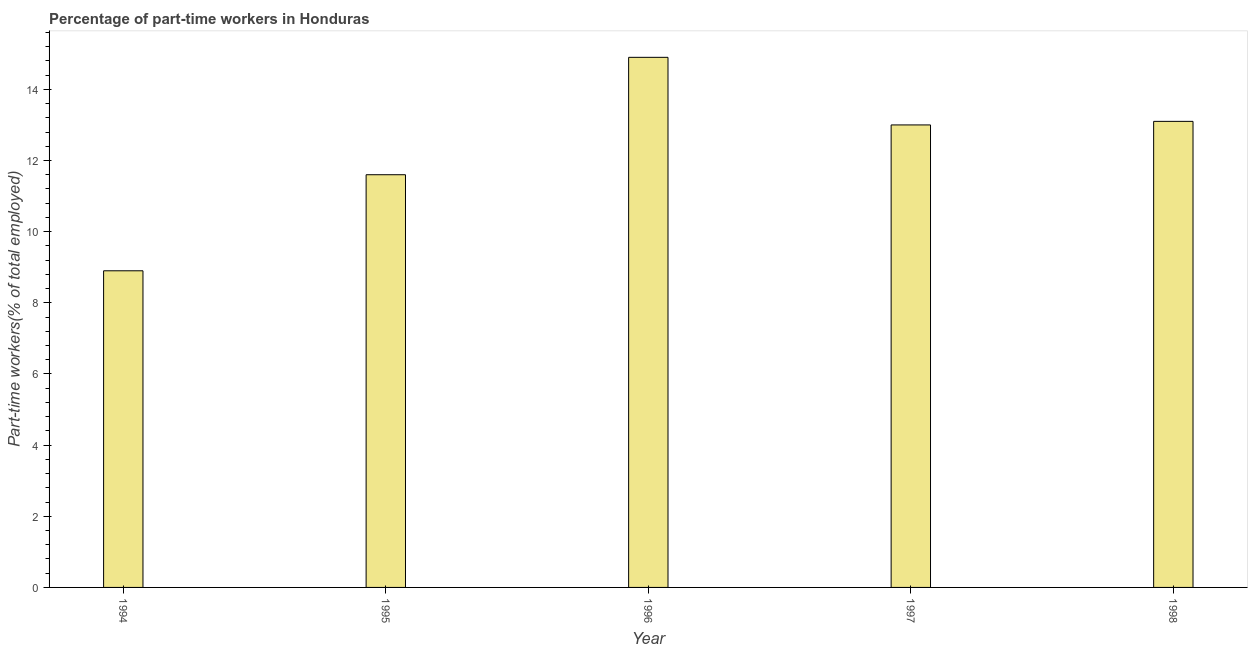What is the title of the graph?
Provide a short and direct response. Percentage of part-time workers in Honduras. What is the label or title of the Y-axis?
Provide a succinct answer. Part-time workers(% of total employed). What is the percentage of part-time workers in 1997?
Your response must be concise. 13. Across all years, what is the maximum percentage of part-time workers?
Keep it short and to the point. 14.9. Across all years, what is the minimum percentage of part-time workers?
Ensure brevity in your answer.  8.9. In which year was the percentage of part-time workers minimum?
Ensure brevity in your answer.  1994. What is the sum of the percentage of part-time workers?
Offer a very short reply. 61.5. What is the difference between the percentage of part-time workers in 1996 and 1997?
Your answer should be compact. 1.9. In how many years, is the percentage of part-time workers greater than 12.8 %?
Provide a short and direct response. 3. What is the ratio of the percentage of part-time workers in 1996 to that in 1998?
Your answer should be very brief. 1.14. Is the percentage of part-time workers in 1996 less than that in 1998?
Give a very brief answer. No. What is the difference between the highest and the lowest percentage of part-time workers?
Give a very brief answer. 6. How many bars are there?
Ensure brevity in your answer.  5. How many years are there in the graph?
Your answer should be very brief. 5. Are the values on the major ticks of Y-axis written in scientific E-notation?
Give a very brief answer. No. What is the Part-time workers(% of total employed) in 1994?
Your answer should be compact. 8.9. What is the Part-time workers(% of total employed) in 1995?
Your response must be concise. 11.6. What is the Part-time workers(% of total employed) of 1996?
Keep it short and to the point. 14.9. What is the Part-time workers(% of total employed) of 1998?
Provide a succinct answer. 13.1. What is the difference between the Part-time workers(% of total employed) in 1994 and 1995?
Your answer should be compact. -2.7. What is the difference between the Part-time workers(% of total employed) in 1994 and 1998?
Ensure brevity in your answer.  -4.2. What is the difference between the Part-time workers(% of total employed) in 1995 and 1997?
Keep it short and to the point. -1.4. What is the difference between the Part-time workers(% of total employed) in 1995 and 1998?
Your answer should be very brief. -1.5. What is the difference between the Part-time workers(% of total employed) in 1996 and 1997?
Your answer should be compact. 1.9. What is the difference between the Part-time workers(% of total employed) in 1996 and 1998?
Make the answer very short. 1.8. What is the ratio of the Part-time workers(% of total employed) in 1994 to that in 1995?
Your answer should be compact. 0.77. What is the ratio of the Part-time workers(% of total employed) in 1994 to that in 1996?
Your answer should be compact. 0.6. What is the ratio of the Part-time workers(% of total employed) in 1994 to that in 1997?
Give a very brief answer. 0.69. What is the ratio of the Part-time workers(% of total employed) in 1994 to that in 1998?
Offer a very short reply. 0.68. What is the ratio of the Part-time workers(% of total employed) in 1995 to that in 1996?
Offer a very short reply. 0.78. What is the ratio of the Part-time workers(% of total employed) in 1995 to that in 1997?
Your answer should be compact. 0.89. What is the ratio of the Part-time workers(% of total employed) in 1995 to that in 1998?
Your response must be concise. 0.89. What is the ratio of the Part-time workers(% of total employed) in 1996 to that in 1997?
Your answer should be very brief. 1.15. What is the ratio of the Part-time workers(% of total employed) in 1996 to that in 1998?
Offer a very short reply. 1.14. 